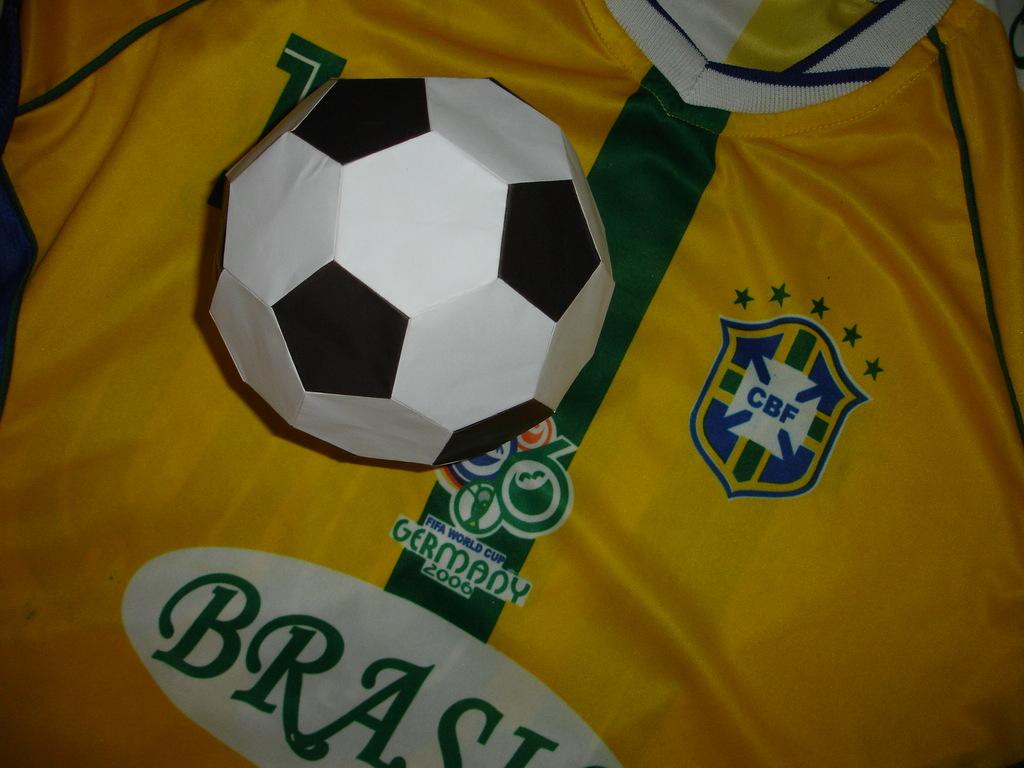What year is shown on the shirt?
Your answer should be very brief. 2006. What kind of ball is on the shirt?
Provide a short and direct response. Answering does not require reading text in the image. 